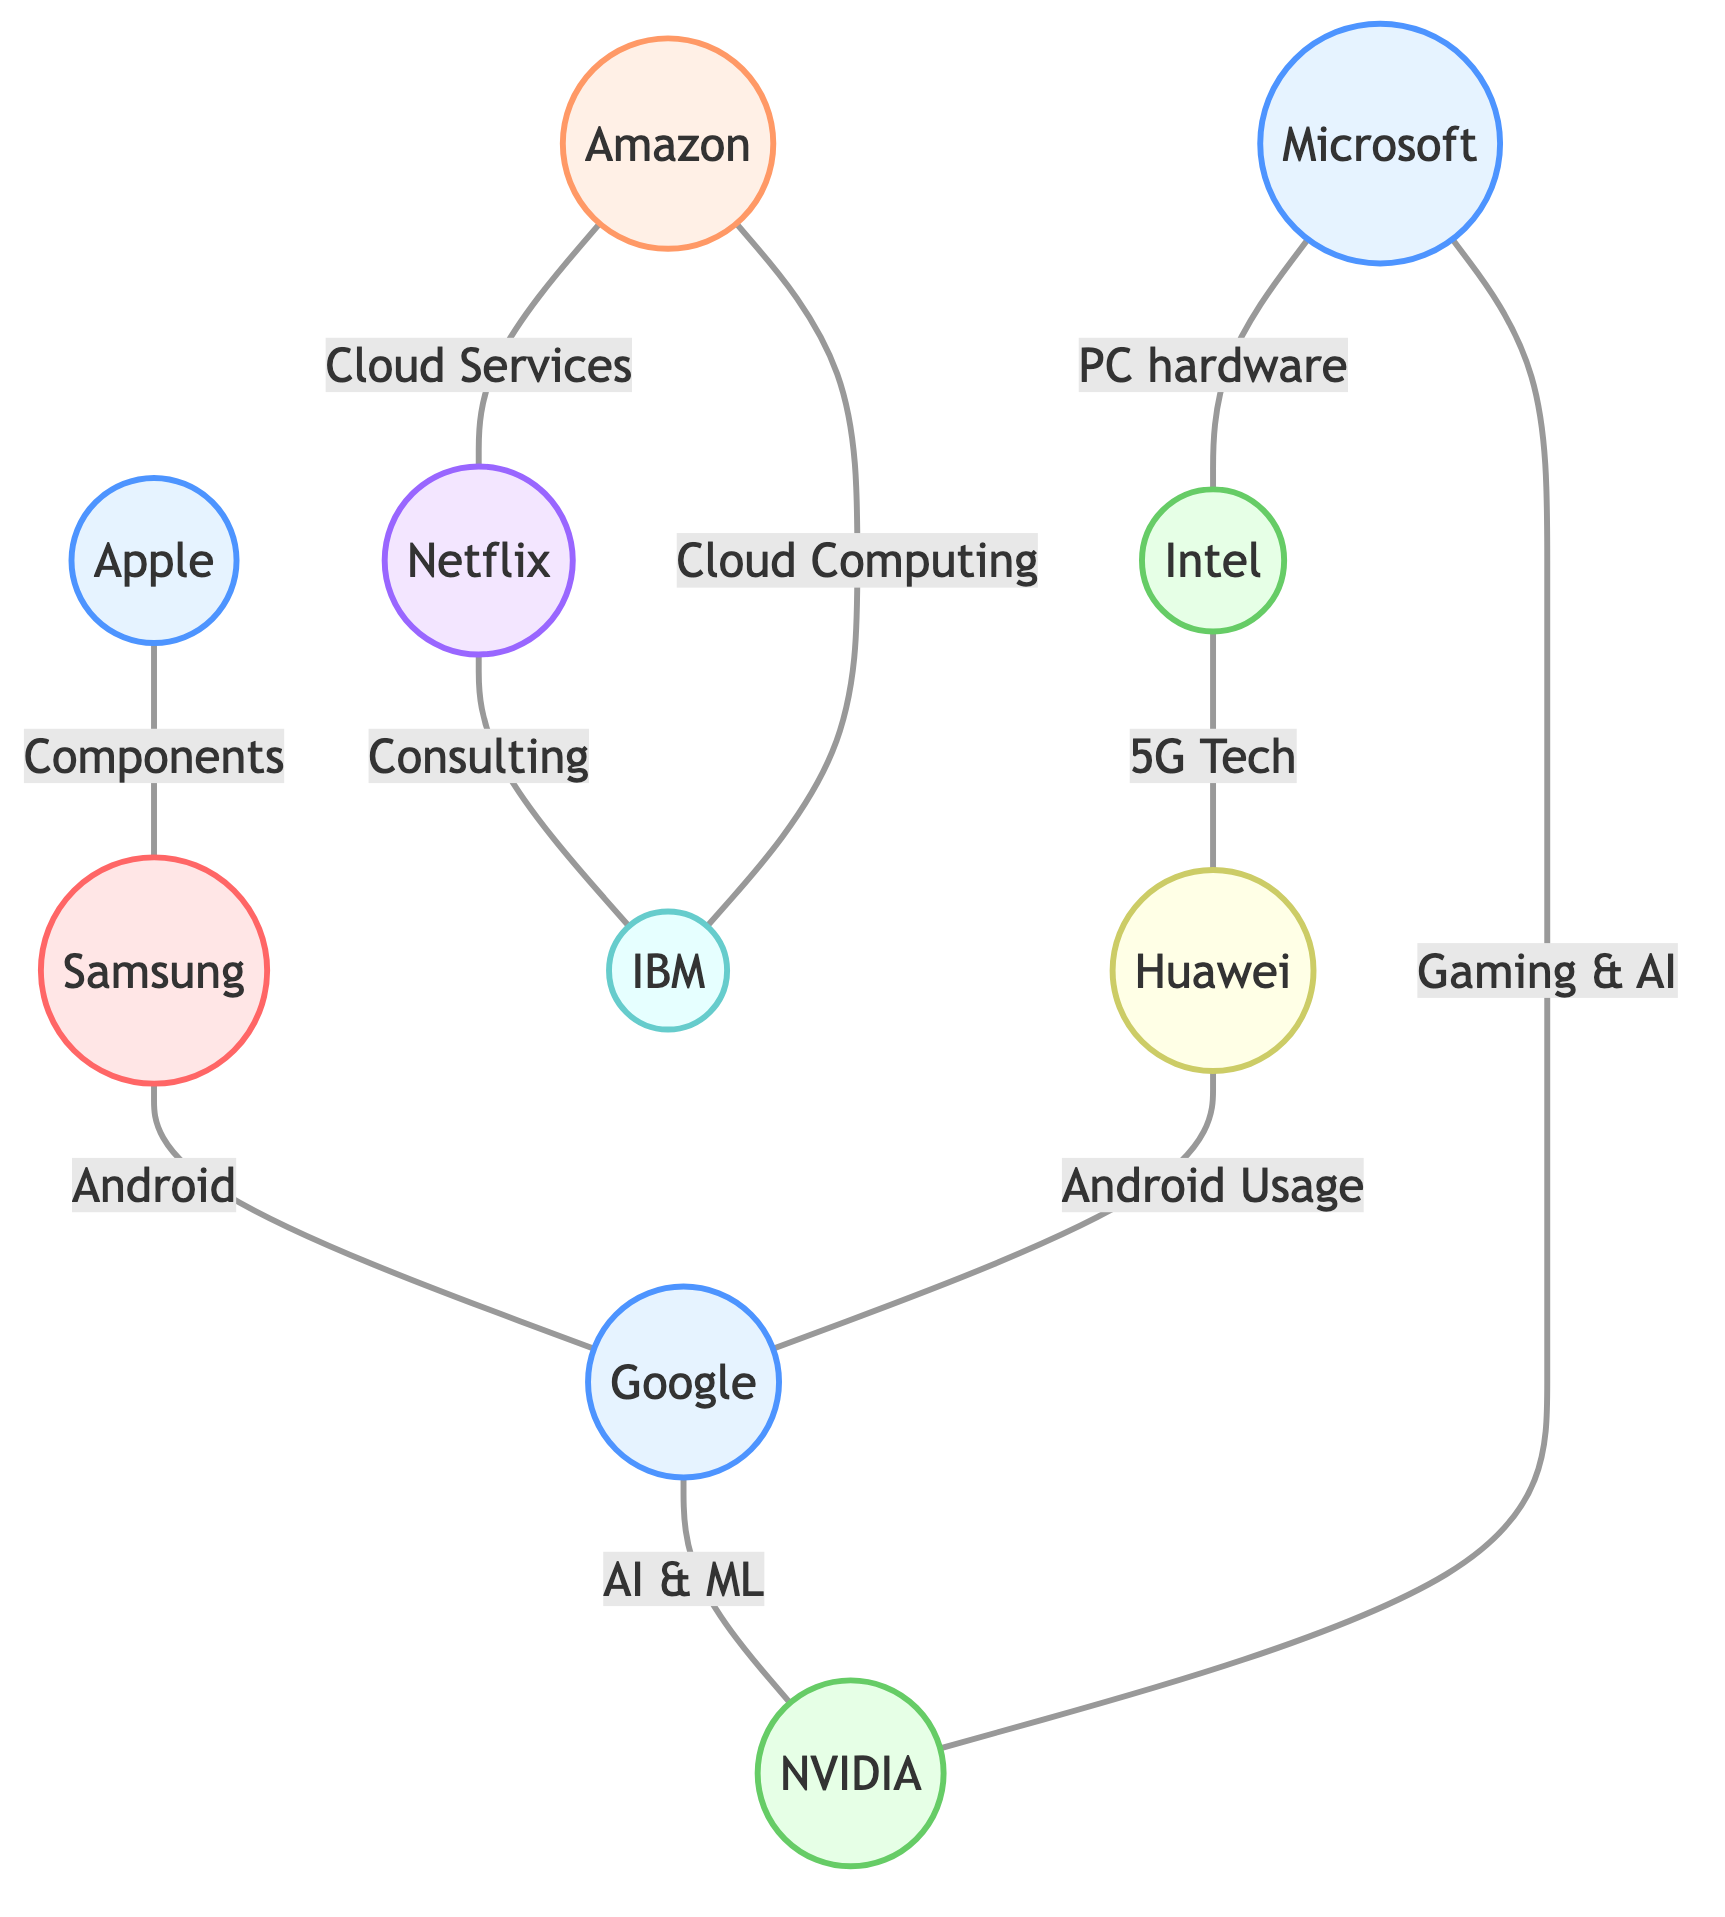What is the total number of nodes in the diagram? The diagram lists ten distinct entities under the "nodes" section, each representing a technology company or related entity. Therefore, we can count these nodes to determine the total.
Answer: 10 Which two companies collaborate on PC hardware? Referring to the "edges" section, the relationship labeled "Collaboration on PC hardware" specifically connects Microsoft and Intel.
Answer: Microsoft and Intel How many edges connect to Amazon? By examining the connections in the "edges" section, Amazon is linked to two entities: Netflix and IBM. Thus, we count these connections to get the total edges associated with Amazon.
Answer: 2 Which company is a supplier of components to Apple? The relationship labeled "Supplier of components" shows a direct connection from Apple to Samsung in the "edges" section. Therefore, Samsung fulfills this role.
Answer: Samsung What type of company is Intel? In the "nodes" section, Intel is specified as a "Semiconductor" company. This classification clearly identifies its industry type within the diagram.
Answer: Semiconductor Which two companies are involved in Android Technology? Looking through the "edges", both Samsung and Huawei have relationships with Google pertaining to Android Technology. Hence, these three entities are identified in this context.
Answer: Samsung and Huawei What is Amazon's relationship with Netflix? The "edges" section states that Amazon provides "AWS Cloud Services" to Netflix. This implies a connection where Amazon supports Netflix's streaming service needs.
Answer: AWS Cloud Services Which company does NVIDIA have a partnership with for Gaming and AI? The diagram details that NVIDIA has a partnership on Gaming and AI with Microsoft, which is explicitly mentioned under "edges." Therefore, these two companies collaborate in this area.
Answer: Microsoft How many types of companies are represented in the diagram? From the "nodes" section, we can identify different types such as Tech Company, E-commerce/Cloud Services, Semiconductor, Consumer Electronics, Streaming Services, Technology and Consulting, and Telecommunications. This classification provides a comprehensive range of types represented.
Answer: 7 Which company is linked to IBM for consulting services? According to the "edges," Netflix has a specified relationship with IBM labeled as "Consulting Services." By looking at this connection, we can identify the company collaborating with IBM.
Answer: Netflix 